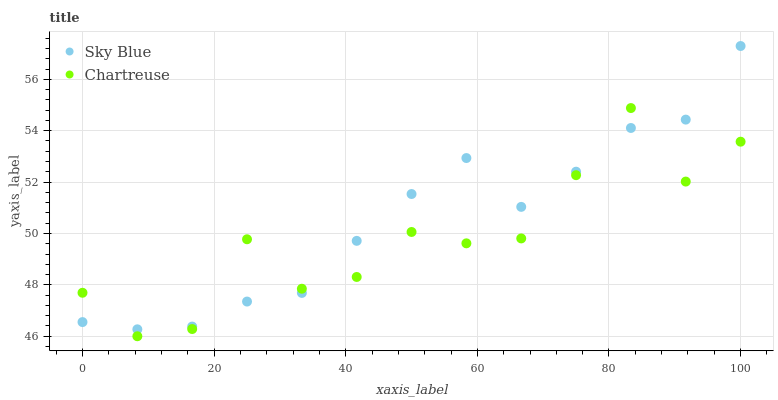Does Chartreuse have the minimum area under the curve?
Answer yes or no. Yes. Does Sky Blue have the maximum area under the curve?
Answer yes or no. Yes. Does Chartreuse have the maximum area under the curve?
Answer yes or no. No. Is Sky Blue the smoothest?
Answer yes or no. Yes. Is Chartreuse the roughest?
Answer yes or no. Yes. Is Chartreuse the smoothest?
Answer yes or no. No. Does Chartreuse have the lowest value?
Answer yes or no. Yes. Does Sky Blue have the highest value?
Answer yes or no. Yes. Does Chartreuse have the highest value?
Answer yes or no. No. Does Sky Blue intersect Chartreuse?
Answer yes or no. Yes. Is Sky Blue less than Chartreuse?
Answer yes or no. No. Is Sky Blue greater than Chartreuse?
Answer yes or no. No. 